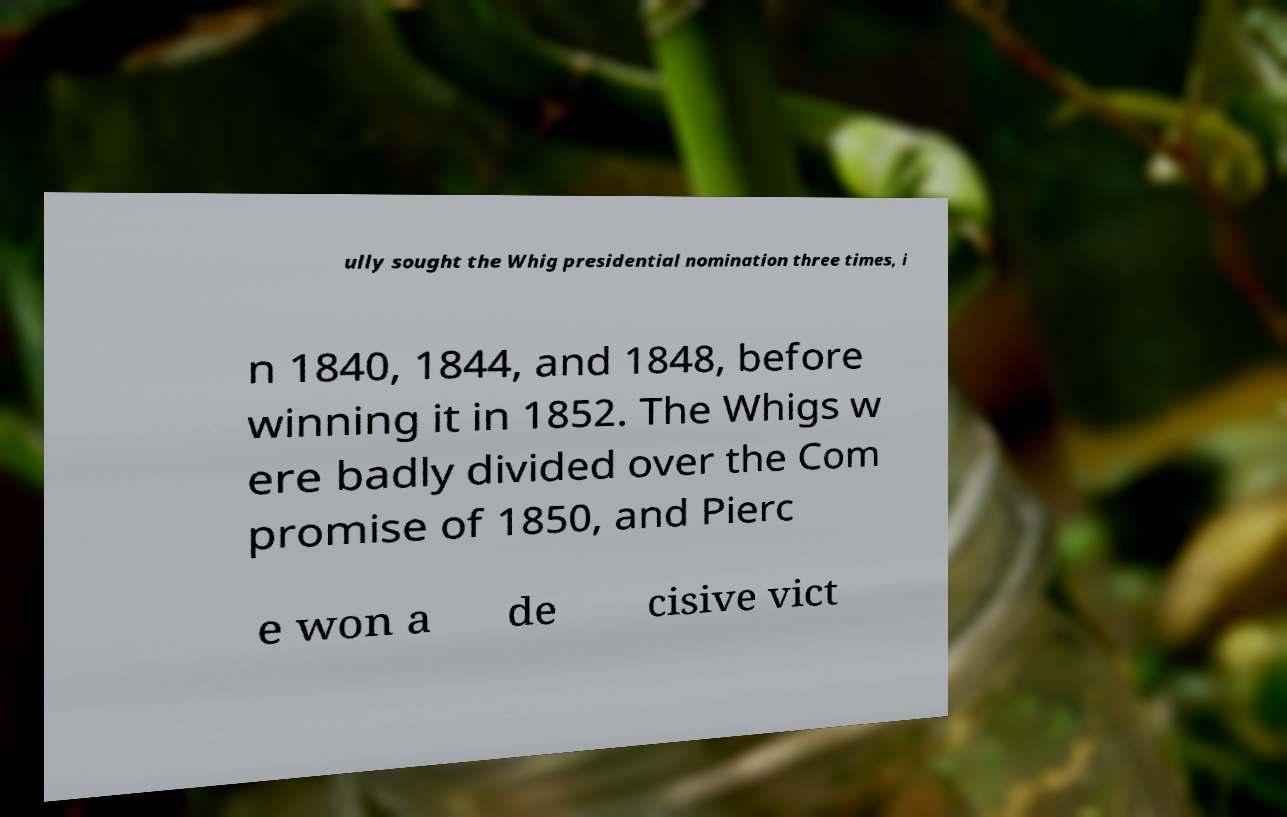I need the written content from this picture converted into text. Can you do that? ully sought the Whig presidential nomination three times, i n 1840, 1844, and 1848, before winning it in 1852. The Whigs w ere badly divided over the Com promise of 1850, and Pierc e won a de cisive vict 